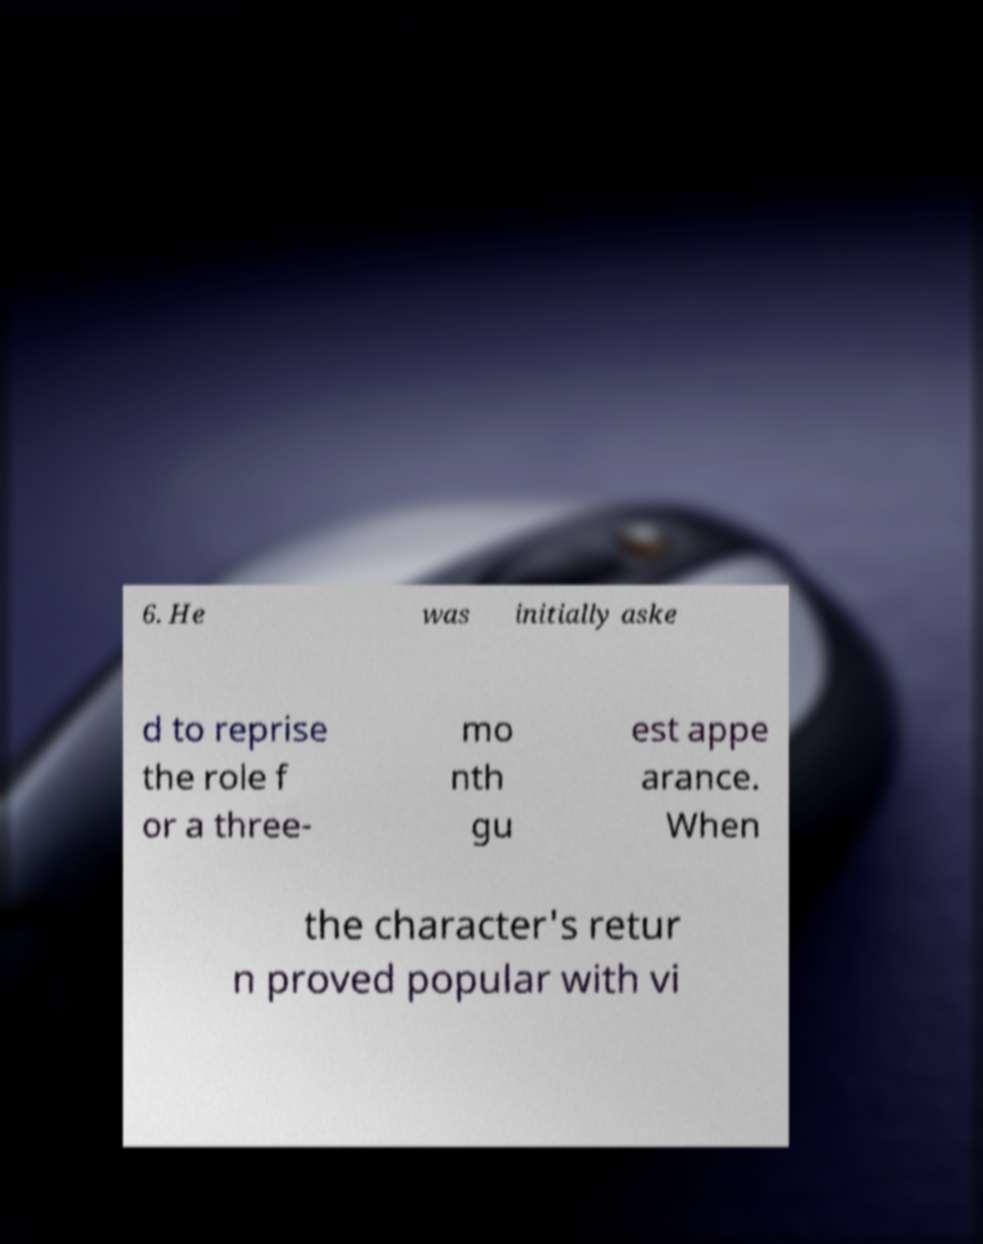Please read and relay the text visible in this image. What does it say? 6. He was initially aske d to reprise the role f or a three- mo nth gu est appe arance. When the character's retur n proved popular with vi 